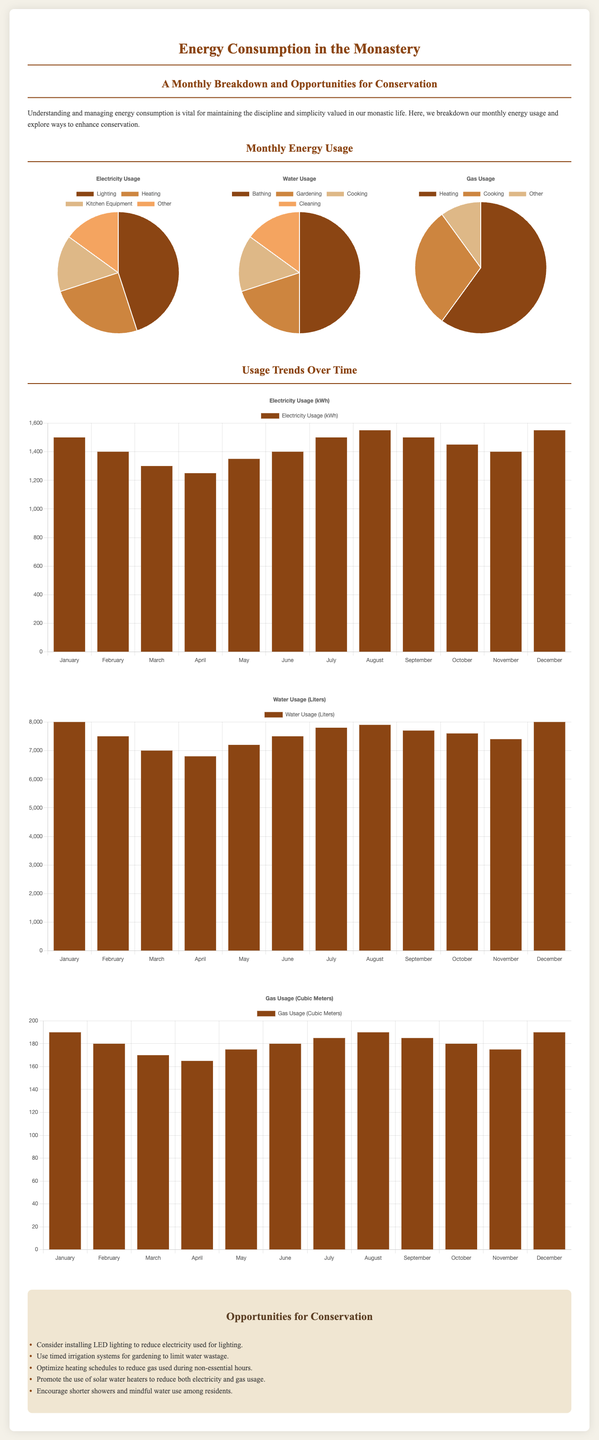What is the primary focus of the infographic? The infographic emphasizes the monthly breakdown of energy usage and conservation opportunities in the monastery.
Answer: Energy usage and conservation How much electricity is used for lighting? The pie chart indicates that 45% of electricity is used for lighting.
Answer: 45% Which activity consumes the most water? According to the water pie chart, bathing consumes the most water at 50%.
Answer: Bathing What was the maximum water usage recorded in the year? The bar chart shows that the maximum water usage recorded was 8000 liters in January and December.
Answer: 8000 liters What percentage of gas is used for heating? The gas pie chart shows that 60% of the gas is used for heating.
Answer: 60% Which month had the highest electricity consumption? The bar chart indicates that the highest electricity consumption occurred in December with 1550 kWh.
Answer: December What conservation opportunity is suggested for gas usage? The document suggests optimizing heating schedules to reduce gas used during non-essential hours.
Answer: Optimize heating schedules What type of chart displays electricity usage over time? The document uses a bar chart to display electricity usage trends over time.
Answer: Bar chart How many liters of water were used in April? The water trend chart shows that 6800 liters of water were used in April.
Answer: 6800 liters 